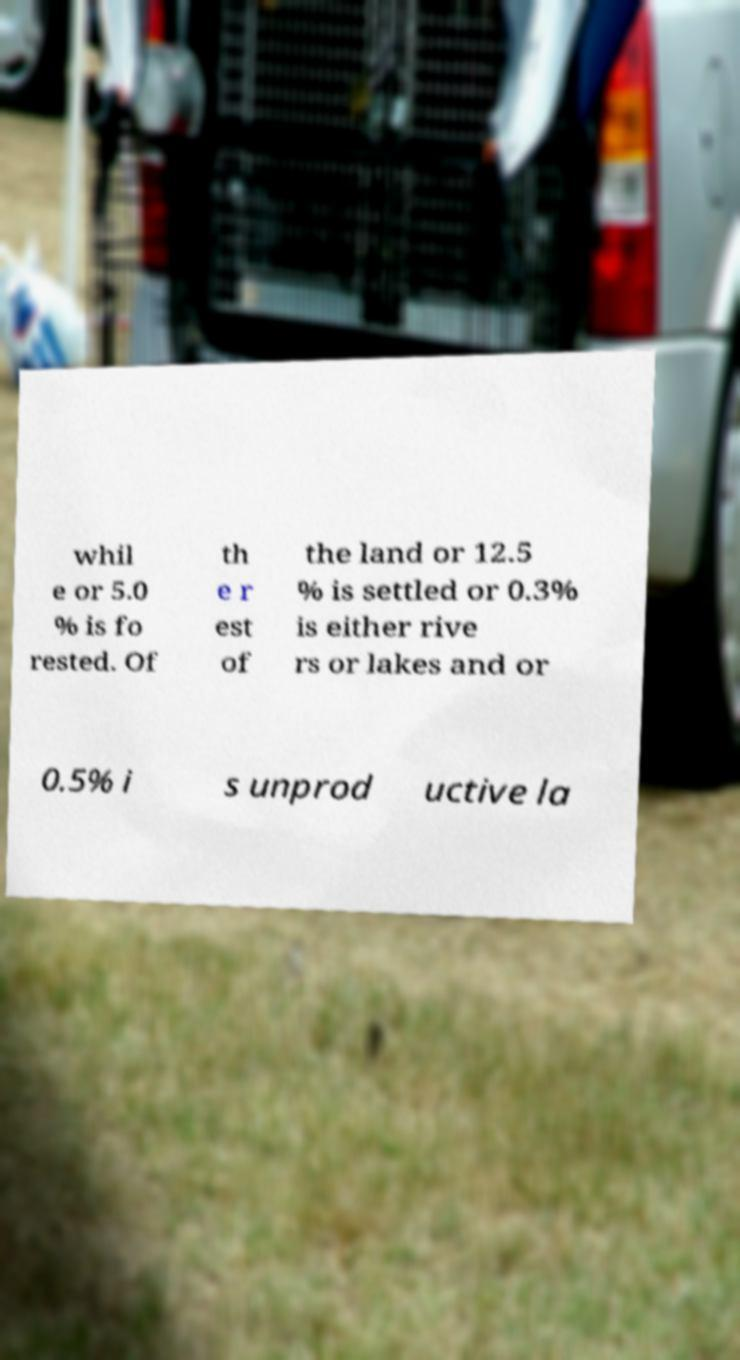I need the written content from this picture converted into text. Can you do that? whil e or 5.0 % is fo rested. Of th e r est of the land or 12.5 % is settled or 0.3% is either rive rs or lakes and or 0.5% i s unprod uctive la 